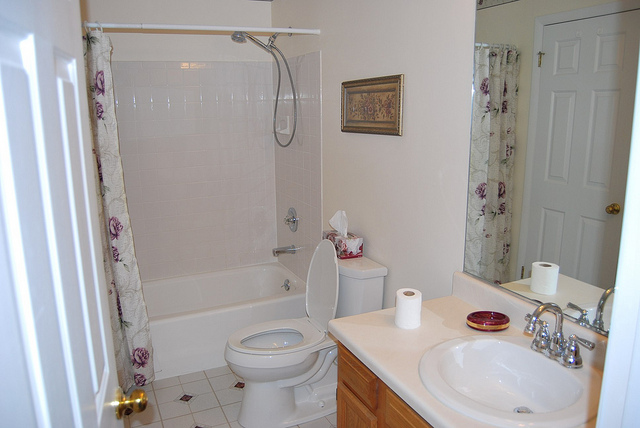<image>What animal is on the curtain? There is no animal on the curtain in the image. What animal is on the curtain? I don't know what animal is on the curtain. It can be seen as a dog, bird, owl or there may be no animal at all. 